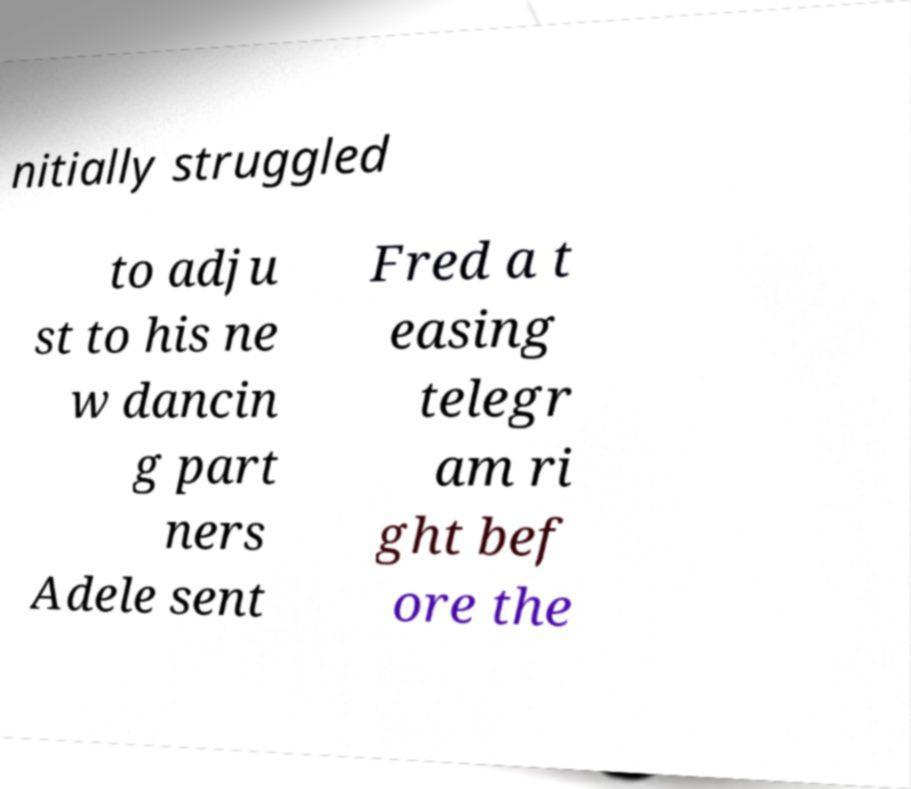Could you extract and type out the text from this image? nitially struggled to adju st to his ne w dancin g part ners Adele sent Fred a t easing telegr am ri ght bef ore the 